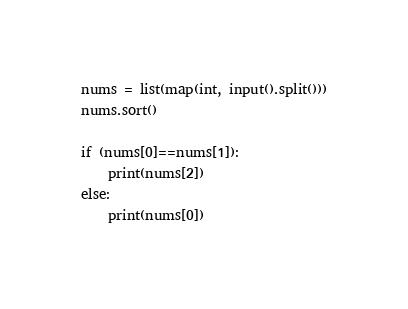<code> <loc_0><loc_0><loc_500><loc_500><_Python_>nums = list(map(int, input().split()))
nums.sort()

if (nums[0]==nums[1]):
    print(nums[2])
else:
    print(nums[0])</code> 